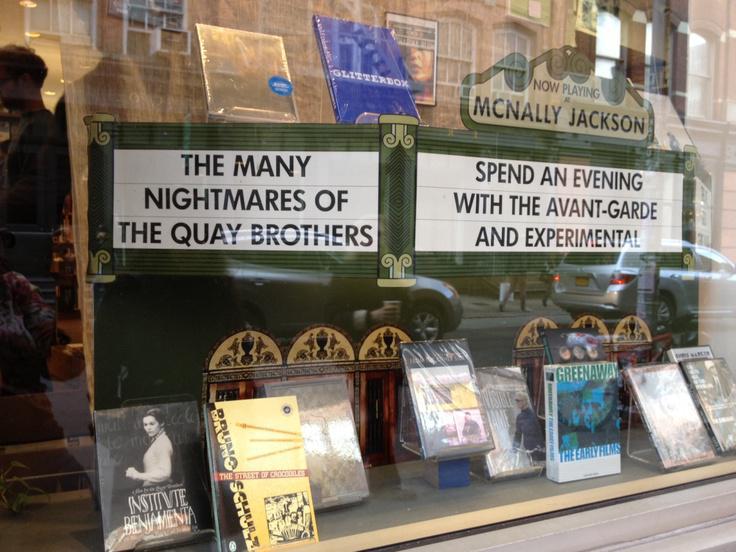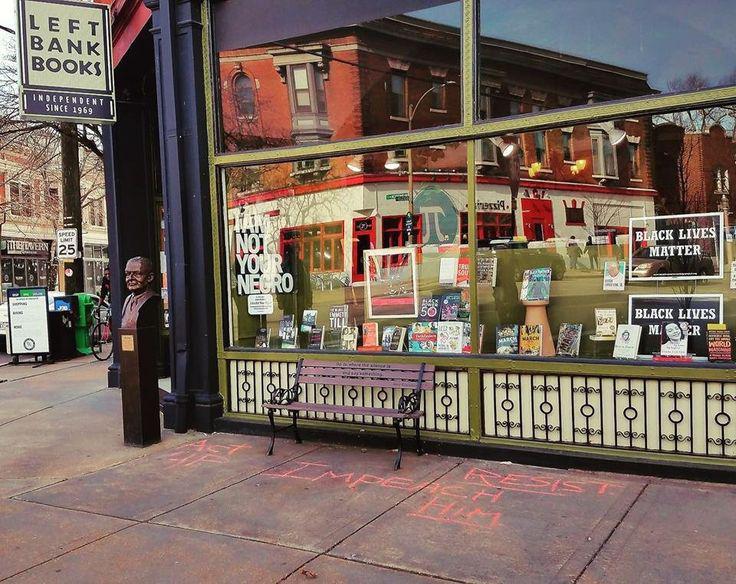The first image is the image on the left, the second image is the image on the right. Given the left and right images, does the statement "There are book shelves outside the store." hold true? Answer yes or no. No. 